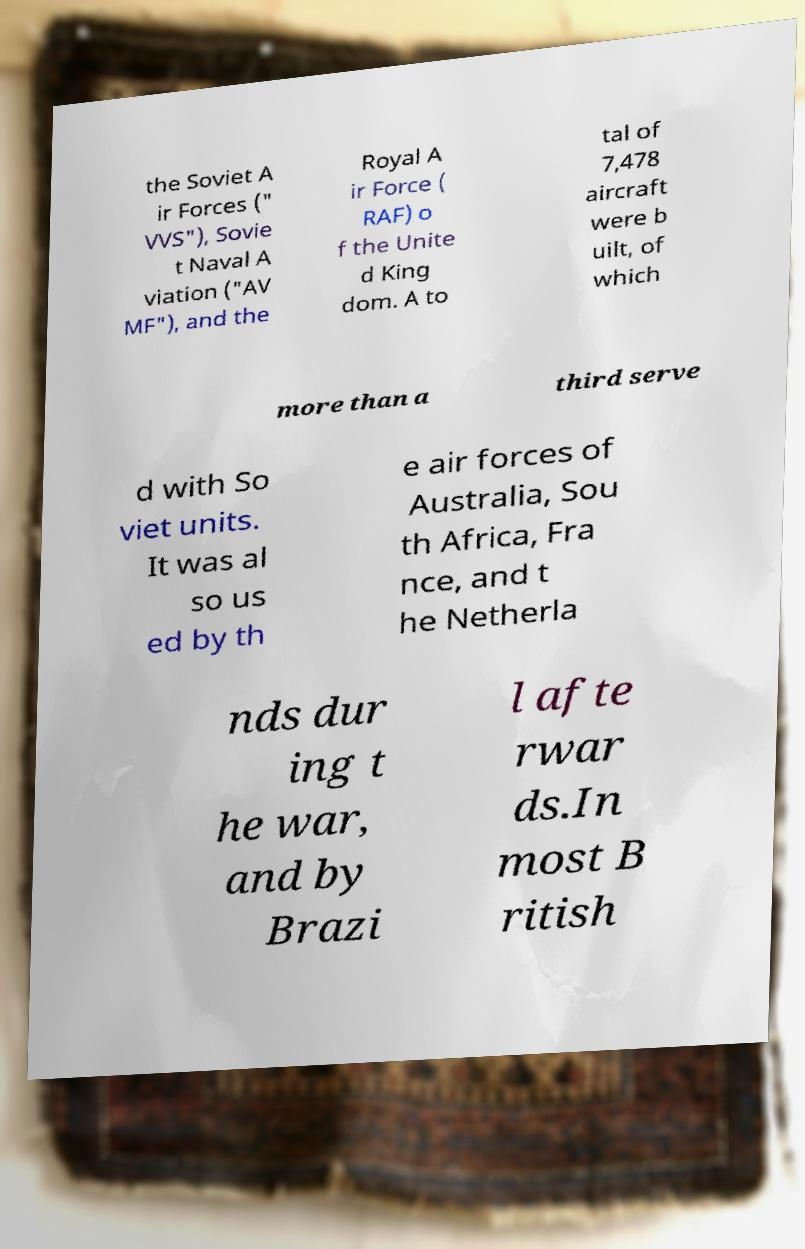What messages or text are displayed in this image? I need them in a readable, typed format. the Soviet A ir Forces (" VVS"), Sovie t Naval A viation ("AV MF"), and the Royal A ir Force ( RAF) o f the Unite d King dom. A to tal of 7,478 aircraft were b uilt, of which more than a third serve d with So viet units. It was al so us ed by th e air forces of Australia, Sou th Africa, Fra nce, and t he Netherla nds dur ing t he war, and by Brazi l afte rwar ds.In most B ritish 